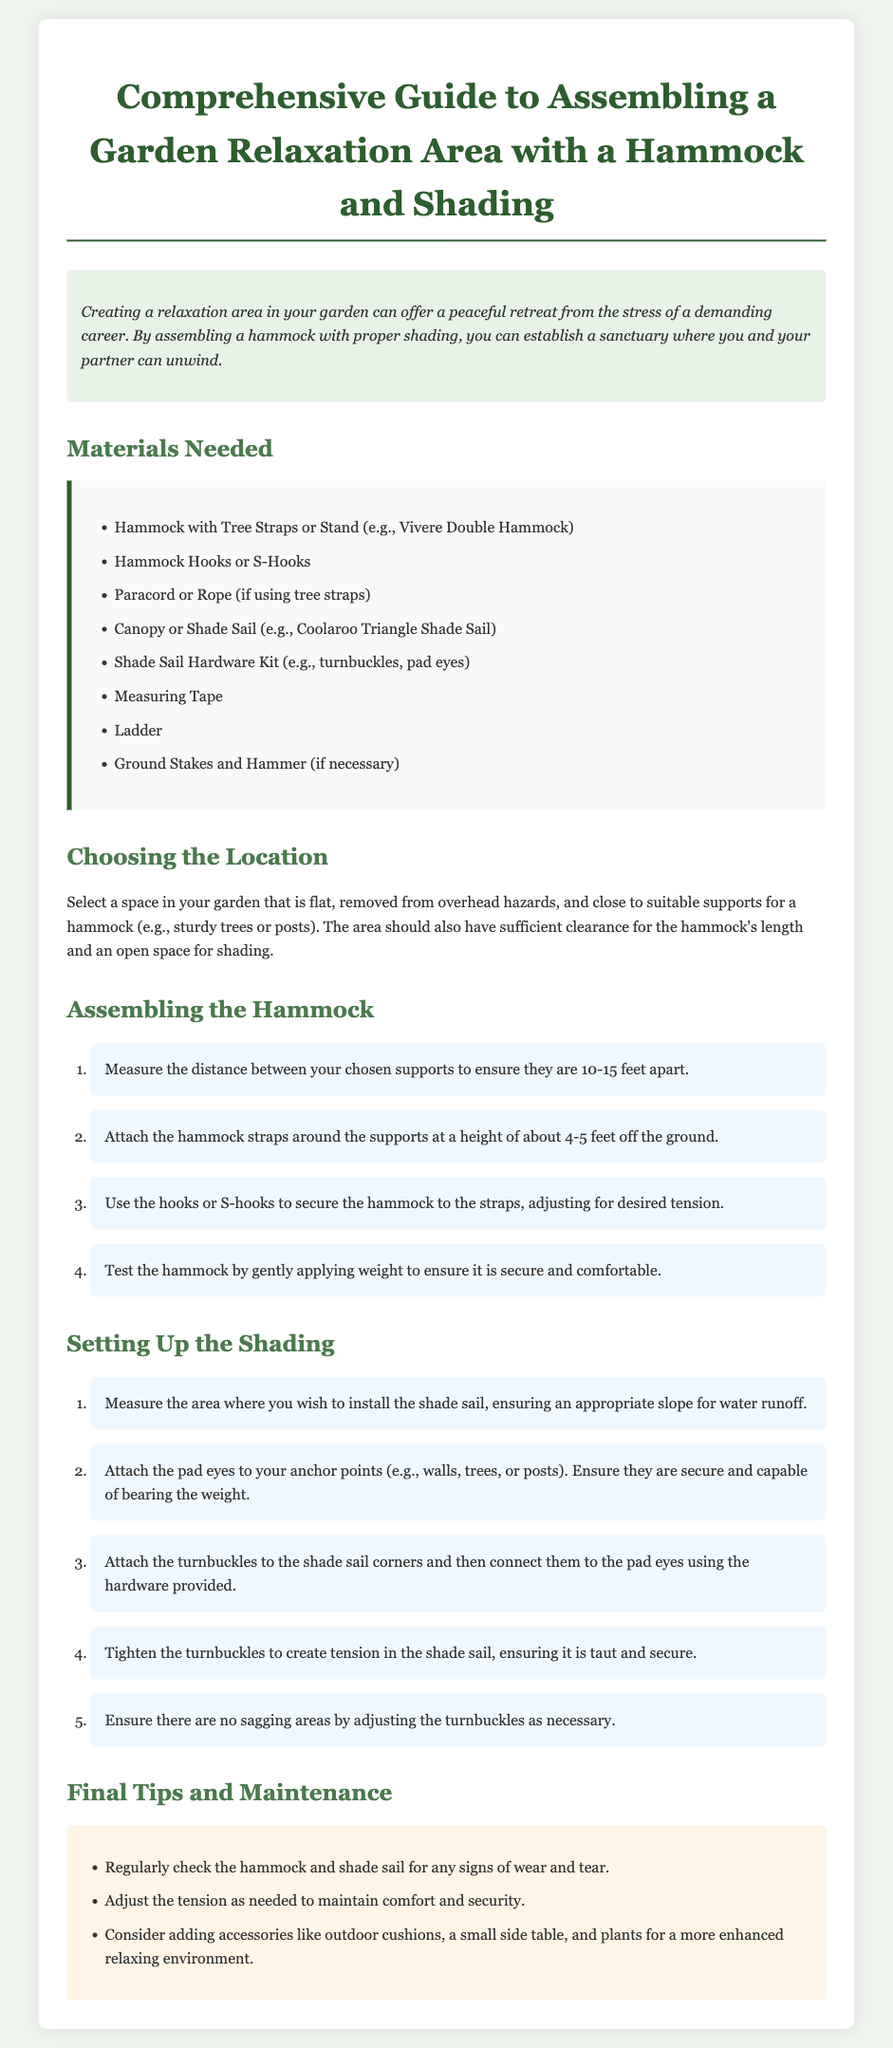What is the title of the document? The title of the document is found at the top of the page.
Answer: Comprehensive Guide to Assembling a Garden Relaxation Area with a Hammock and Shading How many feet apart should the supports for the hammock be? The document specifies the distance for the supports in the assembling steps.
Answer: 10-15 feet What type of hammock is suggested in the materials needed? The materials section lists a specific example of a hammock.
Answer: Vivere Double Hammock What hardware is recommended for the shade sail? This information is found in the materials section related to the shade sail setup.
Answer: Shade Sail Hardware Kit What is one of the final tips for maintenance? The tips section suggests checking for a specific issue regarding the hammock and shade sail.
Answer: Signs of wear and tear Why is it important to measure the area for the shade sail? This reasoning comes from ensuring proper installation and efficacy of the shading.
Answer: Appropriate slope for water runoff What height should the hammock straps be attached to the support? The step for assembling the hammock provides this specific measurement.
Answer: 4-5 feet What should you consider adding to enhance the relaxation area? The final tips suggest some additional items for comfort.
Answer: Outdoor cushions, a small side table, and plants 